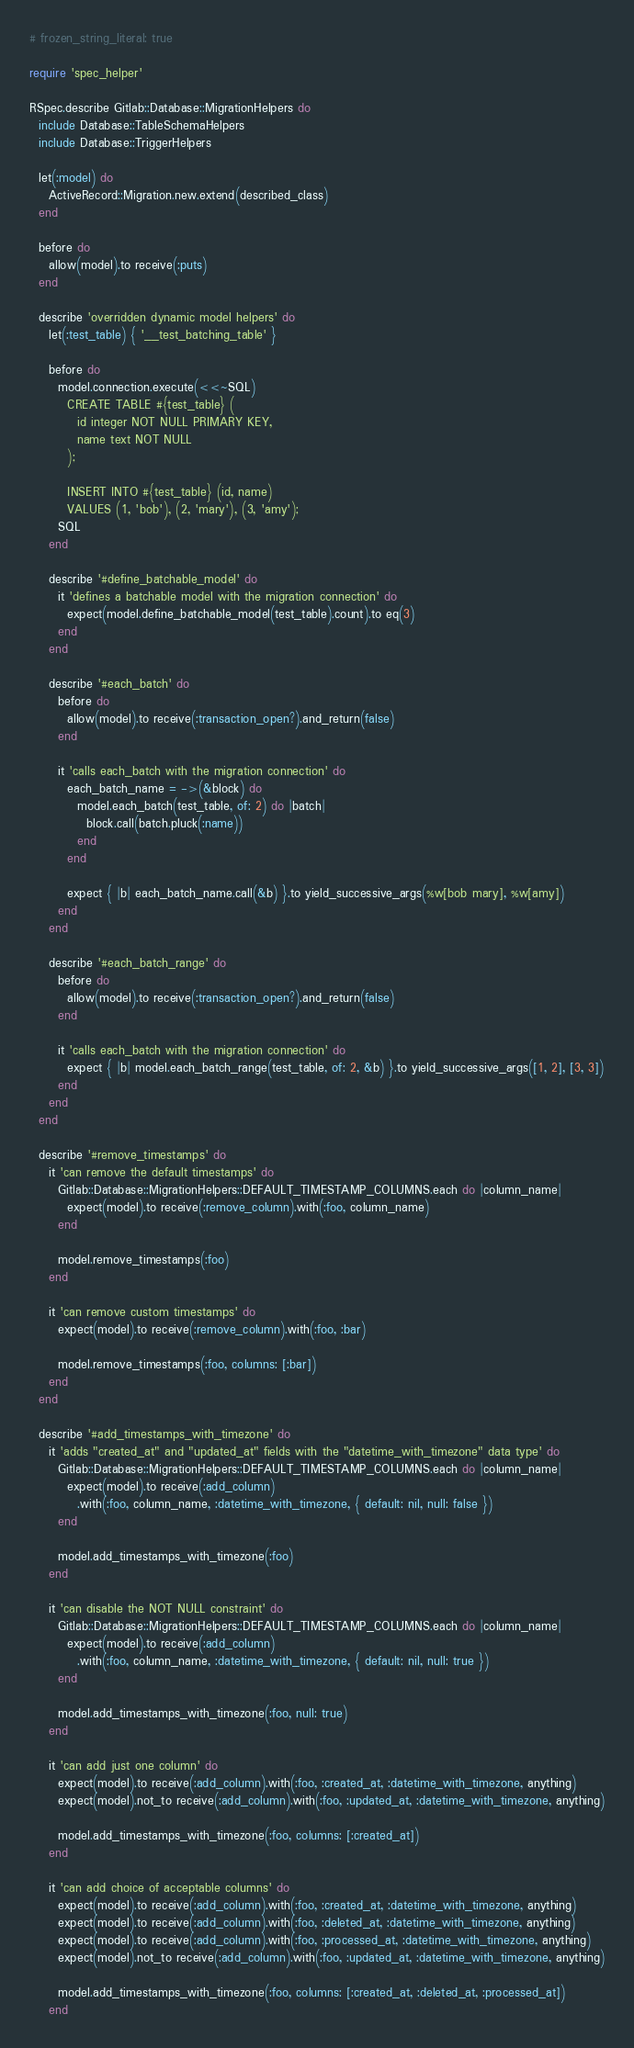Convert code to text. <code><loc_0><loc_0><loc_500><loc_500><_Ruby_># frozen_string_literal: true

require 'spec_helper'

RSpec.describe Gitlab::Database::MigrationHelpers do
  include Database::TableSchemaHelpers
  include Database::TriggerHelpers

  let(:model) do
    ActiveRecord::Migration.new.extend(described_class)
  end

  before do
    allow(model).to receive(:puts)
  end

  describe 'overridden dynamic model helpers' do
    let(:test_table) { '__test_batching_table' }

    before do
      model.connection.execute(<<~SQL)
        CREATE TABLE #{test_table} (
          id integer NOT NULL PRIMARY KEY,
          name text NOT NULL
        );

        INSERT INTO #{test_table} (id, name)
        VALUES (1, 'bob'), (2, 'mary'), (3, 'amy');
      SQL
    end

    describe '#define_batchable_model' do
      it 'defines a batchable model with the migration connection' do
        expect(model.define_batchable_model(test_table).count).to eq(3)
      end
    end

    describe '#each_batch' do
      before do
        allow(model).to receive(:transaction_open?).and_return(false)
      end

      it 'calls each_batch with the migration connection' do
        each_batch_name = ->(&block) do
          model.each_batch(test_table, of: 2) do |batch|
            block.call(batch.pluck(:name))
          end
        end

        expect { |b| each_batch_name.call(&b) }.to yield_successive_args(%w[bob mary], %w[amy])
      end
    end

    describe '#each_batch_range' do
      before do
        allow(model).to receive(:transaction_open?).and_return(false)
      end

      it 'calls each_batch with the migration connection' do
        expect { |b| model.each_batch_range(test_table, of: 2, &b) }.to yield_successive_args([1, 2], [3, 3])
      end
    end
  end

  describe '#remove_timestamps' do
    it 'can remove the default timestamps' do
      Gitlab::Database::MigrationHelpers::DEFAULT_TIMESTAMP_COLUMNS.each do |column_name|
        expect(model).to receive(:remove_column).with(:foo, column_name)
      end

      model.remove_timestamps(:foo)
    end

    it 'can remove custom timestamps' do
      expect(model).to receive(:remove_column).with(:foo, :bar)

      model.remove_timestamps(:foo, columns: [:bar])
    end
  end

  describe '#add_timestamps_with_timezone' do
    it 'adds "created_at" and "updated_at" fields with the "datetime_with_timezone" data type' do
      Gitlab::Database::MigrationHelpers::DEFAULT_TIMESTAMP_COLUMNS.each do |column_name|
        expect(model).to receive(:add_column)
          .with(:foo, column_name, :datetime_with_timezone, { default: nil, null: false })
      end

      model.add_timestamps_with_timezone(:foo)
    end

    it 'can disable the NOT NULL constraint' do
      Gitlab::Database::MigrationHelpers::DEFAULT_TIMESTAMP_COLUMNS.each do |column_name|
        expect(model).to receive(:add_column)
          .with(:foo, column_name, :datetime_with_timezone, { default: nil, null: true })
      end

      model.add_timestamps_with_timezone(:foo, null: true)
    end

    it 'can add just one column' do
      expect(model).to receive(:add_column).with(:foo, :created_at, :datetime_with_timezone, anything)
      expect(model).not_to receive(:add_column).with(:foo, :updated_at, :datetime_with_timezone, anything)

      model.add_timestamps_with_timezone(:foo, columns: [:created_at])
    end

    it 'can add choice of acceptable columns' do
      expect(model).to receive(:add_column).with(:foo, :created_at, :datetime_with_timezone, anything)
      expect(model).to receive(:add_column).with(:foo, :deleted_at, :datetime_with_timezone, anything)
      expect(model).to receive(:add_column).with(:foo, :processed_at, :datetime_with_timezone, anything)
      expect(model).not_to receive(:add_column).with(:foo, :updated_at, :datetime_with_timezone, anything)

      model.add_timestamps_with_timezone(:foo, columns: [:created_at, :deleted_at, :processed_at])
    end
</code> 